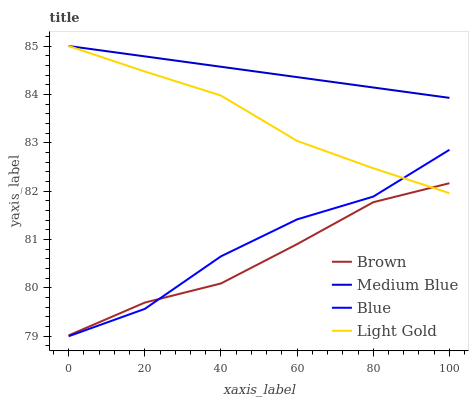Does Brown have the minimum area under the curve?
Answer yes or no. Yes. Does Medium Blue have the maximum area under the curve?
Answer yes or no. Yes. Does Light Gold have the minimum area under the curve?
Answer yes or no. No. Does Light Gold have the maximum area under the curve?
Answer yes or no. No. Is Medium Blue the smoothest?
Answer yes or no. Yes. Is Blue the roughest?
Answer yes or no. Yes. Is Brown the smoothest?
Answer yes or no. No. Is Brown the roughest?
Answer yes or no. No. Does Blue have the lowest value?
Answer yes or no. Yes. Does Brown have the lowest value?
Answer yes or no. No. Does Medium Blue have the highest value?
Answer yes or no. Yes. Does Brown have the highest value?
Answer yes or no. No. Is Brown less than Medium Blue?
Answer yes or no. Yes. Is Medium Blue greater than Brown?
Answer yes or no. Yes. Does Medium Blue intersect Light Gold?
Answer yes or no. Yes. Is Medium Blue less than Light Gold?
Answer yes or no. No. Is Medium Blue greater than Light Gold?
Answer yes or no. No. Does Brown intersect Medium Blue?
Answer yes or no. No. 